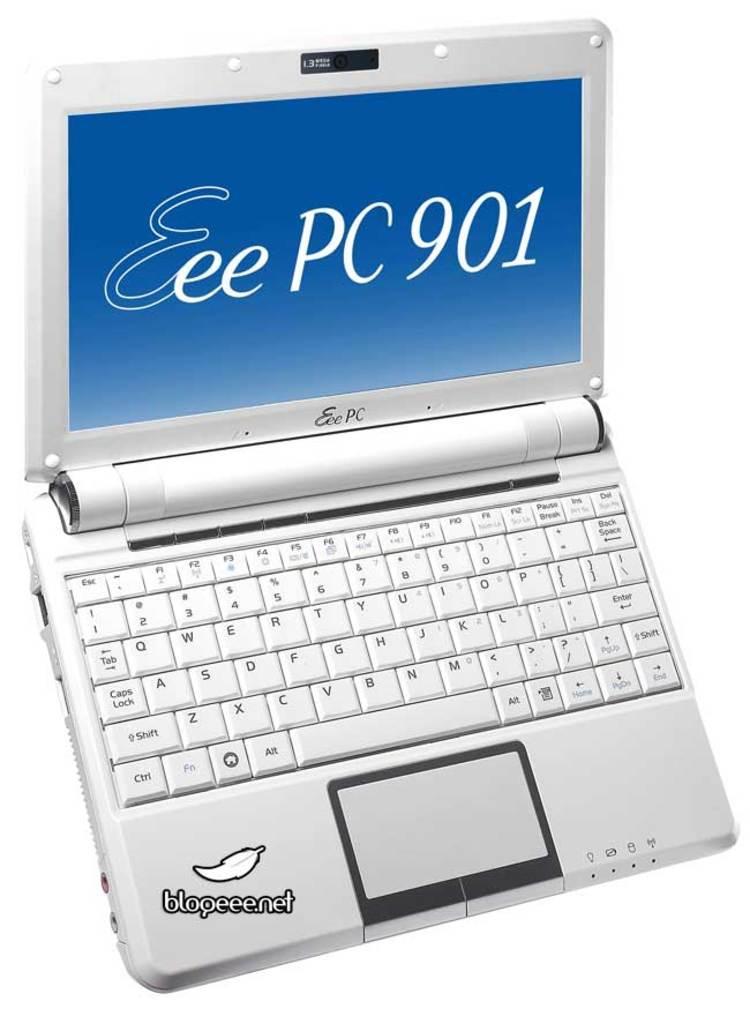<image>
Provide a brief description of the given image. A laptop is open and shows Eee PC 901 on the screen. 